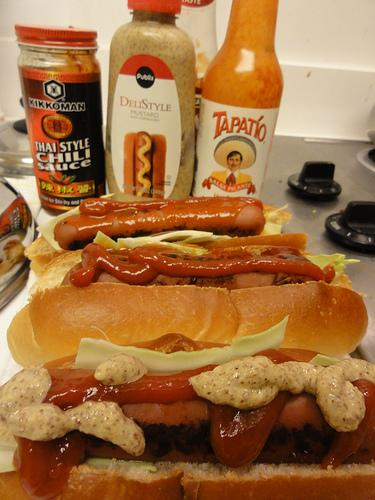Describe the image as if you were presenting it as a piece of art. This composition features hot dogs adorned with vibrant toppings, accompanied by an array of sauce bottles and stark stove knobs, against a minimalist white backdrop. Describe the presence of an appliance in the image and any related elements associated with it. A stove is shown with black knobs or dials, situated amidst the hot dogs and sauce bottles. Illustrate a brief scene taking place in the image, mentioning the main subjects and their surroundings. Hot dogs are dressed with various toppings, resting near bottles of mustard, hot sauce, and chili sauce, and in front of a stove with black knobs. Mention the types of sauces seen in the image along with their respective bottles. There are bottles of deli style mustard, hot sauce, chili sauce, and ketchup, each with distinct lids or caps. Explain the different elements in the image as if you were giving a cooking demonstration. Today, we have hot dogs topped with mustard, ketchup, and cabbage, surrounded by various sauce bottles like mustard and hot sauce, with a stove in the background. Comment on the background and setting of the image. The hot dogs, sauce bottles, and stove knobs are situated against a plain white background, possibly a wall or counter. Enumerate the types of toppings visible on the hot dogs in the image. Mustard, ketchup, cabbage, and possibly some cheese are seen as toppings on the hot dogs. Provide a brief description of the primary elements in the image. Several hot dogs with mustard, ketchup, and cabbage toppings, bottles of mustard, hot sauce, and chili sauce, and knobs on a stove. Narrate the image as if you were telling a friend what's in the picture. Hey, this photo has a bunch of hot dogs with mustard, ketchup, and cabbage on top, plus some sauce bottles and stove knobs in the background. What food item is the central focus of the image? Hot dogs loaded with toppings like mustard, ketchup, and cabbage are the focal points of the image. 